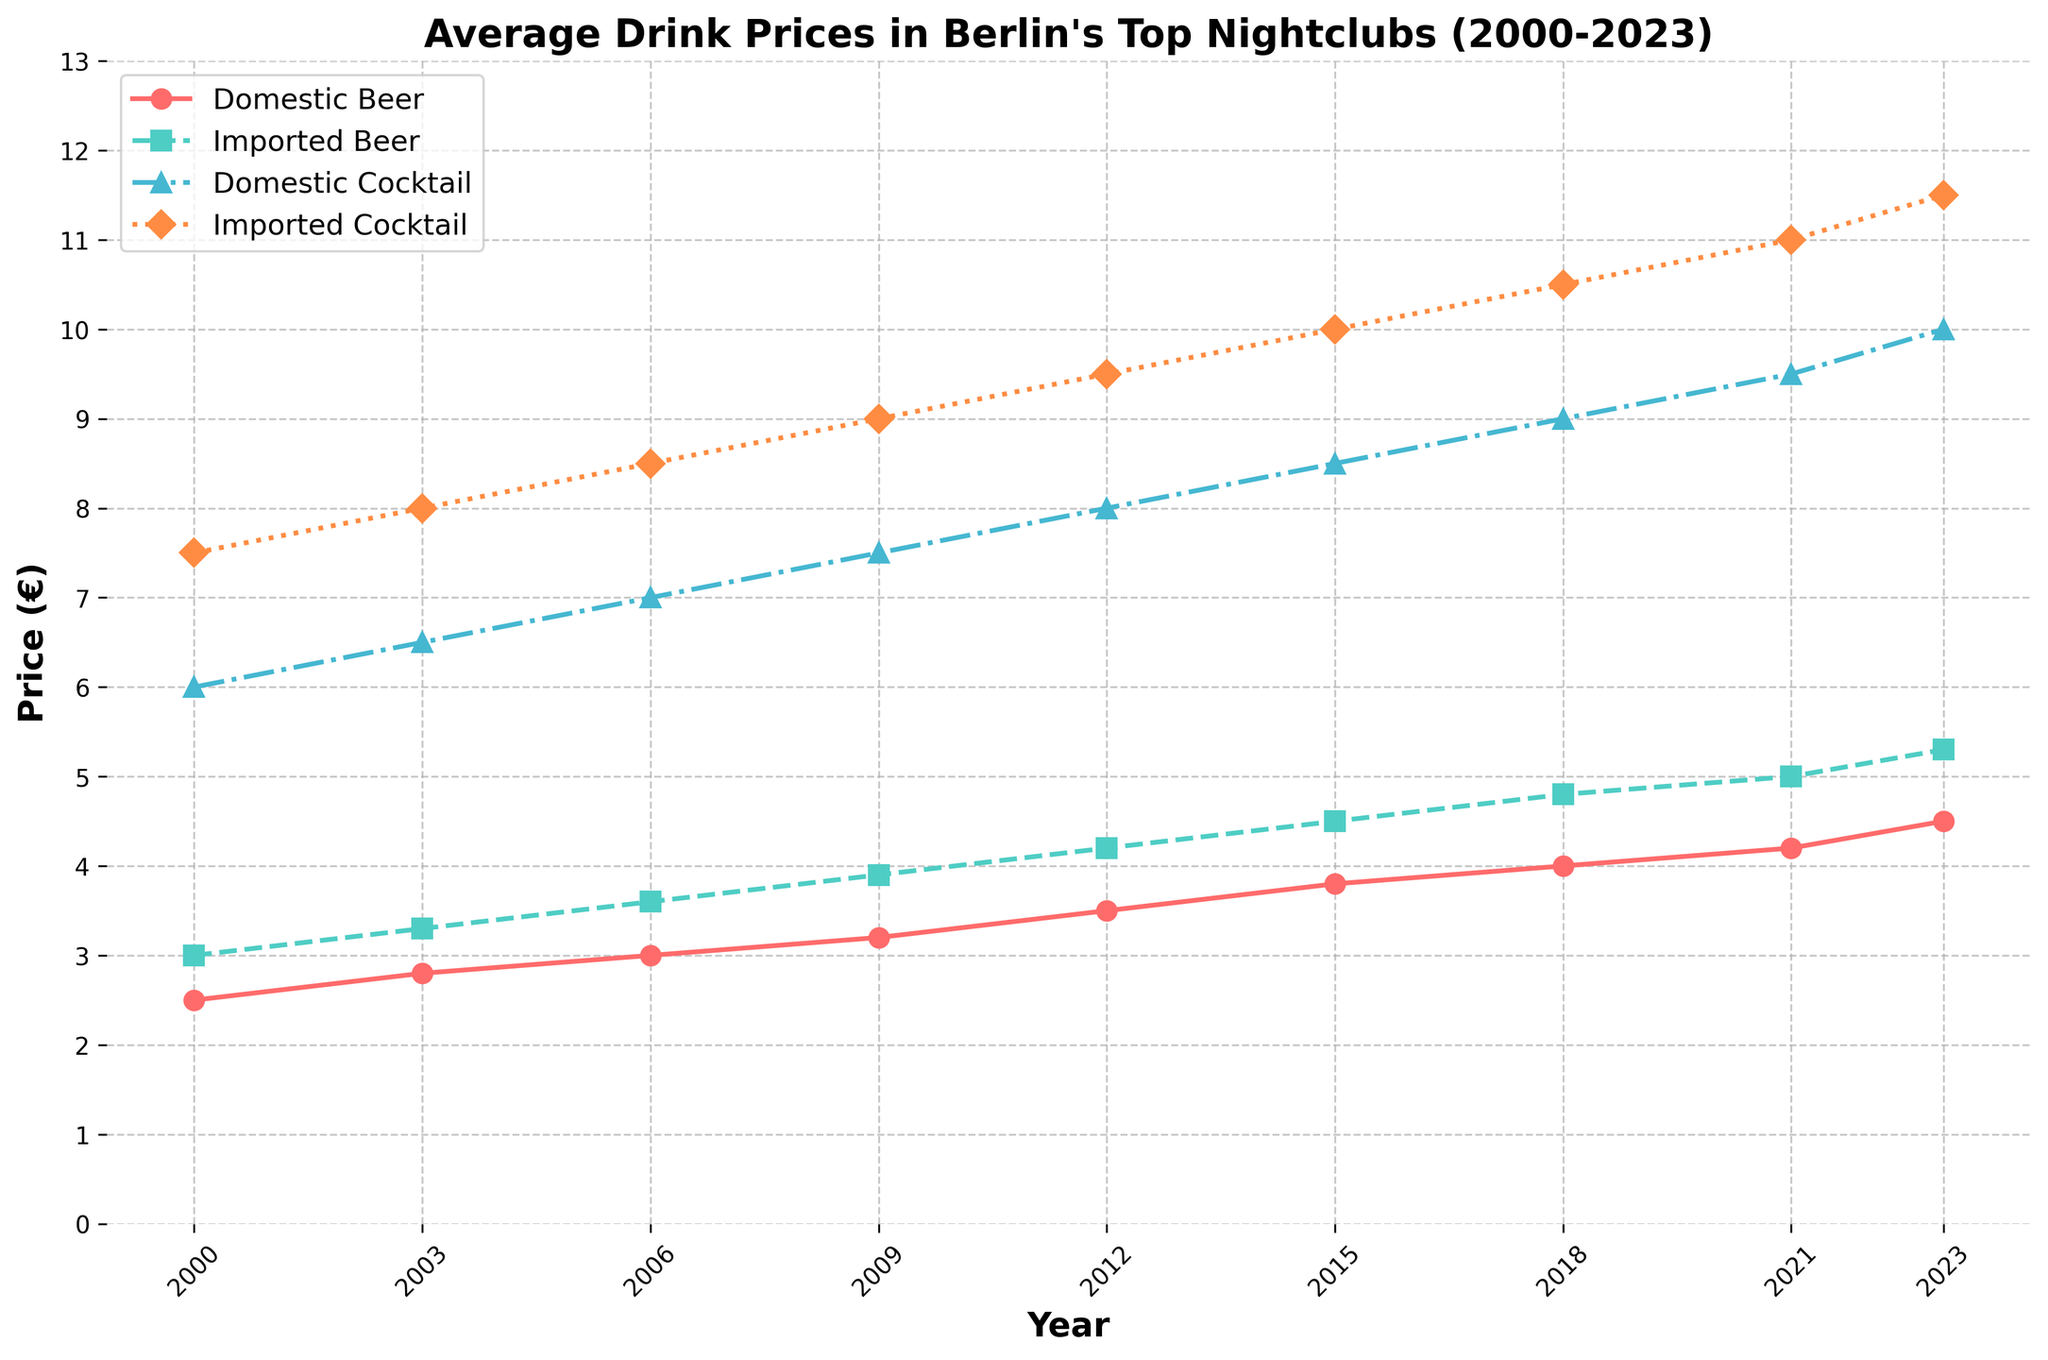What is the price increase for domestic beer from 2000 to 2023? To find the price increase, subtract the 2000 price from the 2023 price for domestic beer. This is 4.50 - 2.50.
Answer: 2.00 Which type of drink has the highest price in 2023? Look at the prices for all types of drinks in 2023. The prices are 4.50 for domestic beer, 5.30 for imported beer, 10.00 for domestic cocktail, and 11.50 for imported cocktail. The highest price is for imported cocktail.
Answer: Imported Cocktail How much did the price of domestic cocktails increase between 2006 and 2021? Subtract the price in 2006 from the price in 2021 for domestic cocktails. This is 9.50 - 7.00.
Answer: 2.50 In which year did imported beer first surpass a price of 4.00? Identify the first year where the price of imported beer is greater than 4.00. This occurs in 2012.
Answer: 2012 Compare the price trends of imported beer and imported cocktails from 2000 to 2023. What can you conclude? Both imported beer and imported cocktails show an increasing trend from 2000 to 2023. However, imported cocktails have a steeper increase in price compared to imported beer.
Answer: Imported cocktails increased faster than imported beer What is the average price of domestic beer over the given years? Add the prices of domestic beer for all given years and divide by the number of years (i.e., (2.50 + 2.80 + 3.00 + 3.20 + 3.50 + 3.80 + 4.00 + 4.20 + 4.50) / 9).
Answer: 3.50 In 2021, which drink had nearly double the price of domestic beer? Compare the 2021 prices, the drink whose price is nearly double of 4.20 (domestic beer) is domestic cocktail, which is 9.50.
Answer: Domestic Cocktail How did the price of domestic beer change from 2003 to 2006? Subtract the 2003 price from the 2006 price for domestic beer. This is 3.00 - 2.80.
Answer: 0.20 What is the difference in price between imported cocktails and domestic beer in 2018? Subtract the 2018 price of domestic beer from the 2018 price of imported cocktails. This is 10.50 - 4.00.
Answer: 6.50 Between which consecutive years did the domestic cocktail prices see the highest increase? Calculate the price increase for each consecutive year pair for domestic cocktails and compare. The highest increase is between 2021 and 2023: 10.00 - 9.50.
Answer: 2021 to 2023 